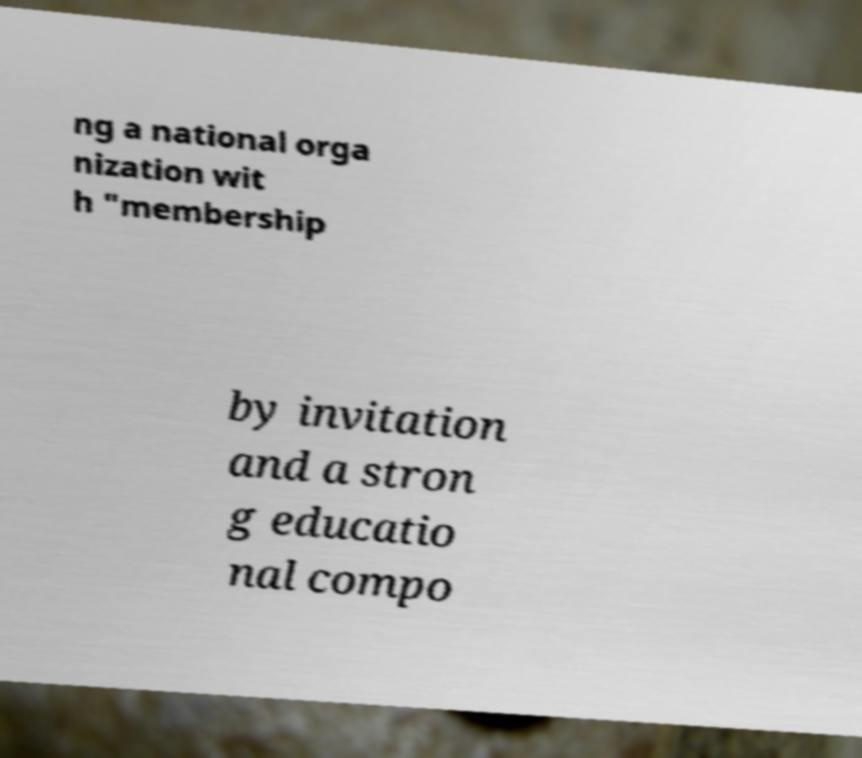Could you assist in decoding the text presented in this image and type it out clearly? ng a national orga nization wit h "membership by invitation and a stron g educatio nal compo 